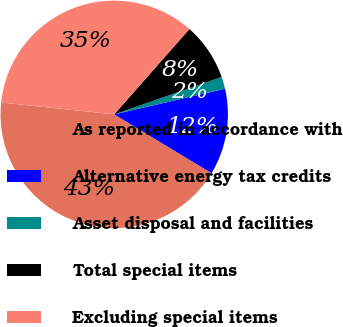<chart> <loc_0><loc_0><loc_500><loc_500><pie_chart><fcel>As reported in accordance with<fcel>Alternative energy tax credits<fcel>Asset disposal and facilities<fcel>Total special items<fcel>Excluding special items<nl><fcel>43.01%<fcel>12.26%<fcel>1.72%<fcel>8.17%<fcel>34.84%<nl></chart> 